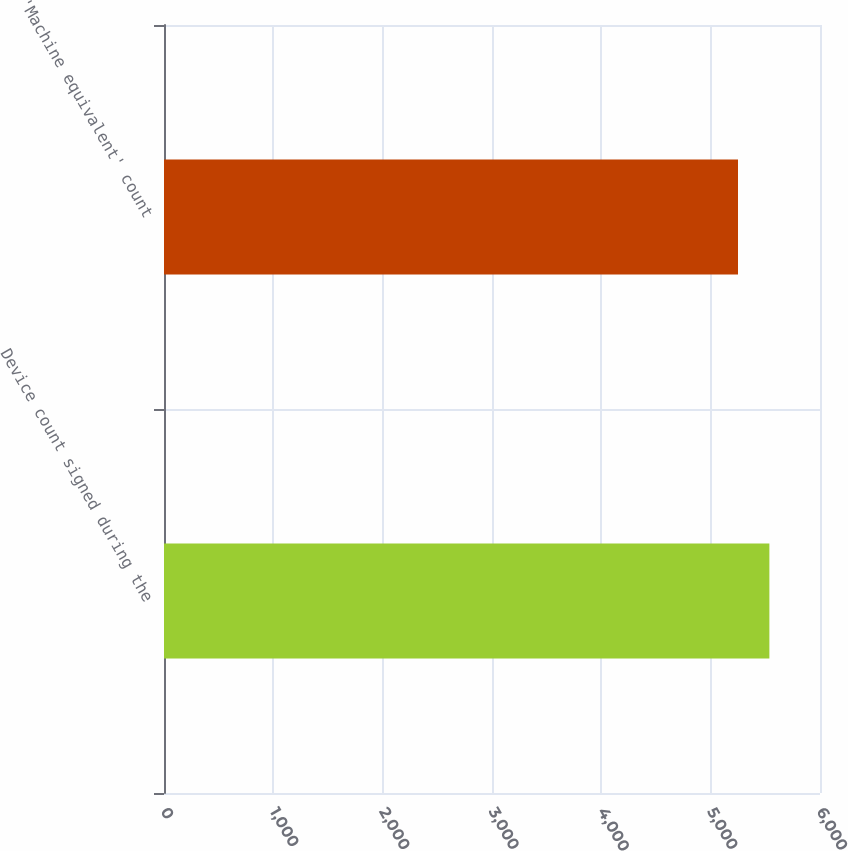<chart> <loc_0><loc_0><loc_500><loc_500><bar_chart><fcel>Device count signed during the<fcel>'Machine equivalent' count<nl><fcel>5537<fcel>5250<nl></chart> 